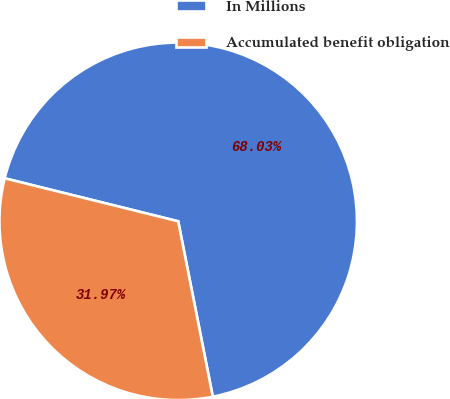Convert chart. <chart><loc_0><loc_0><loc_500><loc_500><pie_chart><fcel>In Millions<fcel>Accumulated benefit obligation<nl><fcel>68.03%<fcel>31.97%<nl></chart> 